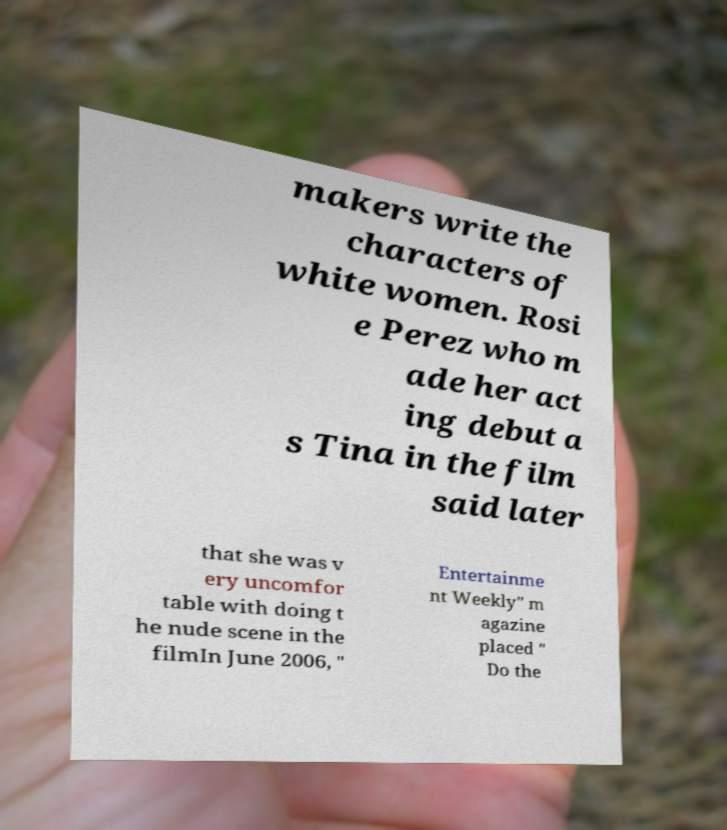Could you extract and type out the text from this image? makers write the characters of white women. Rosi e Perez who m ade her act ing debut a s Tina in the film said later that she was v ery uncomfor table with doing t he nude scene in the filmIn June 2006, " Entertainme nt Weekly" m agazine placed " Do the 